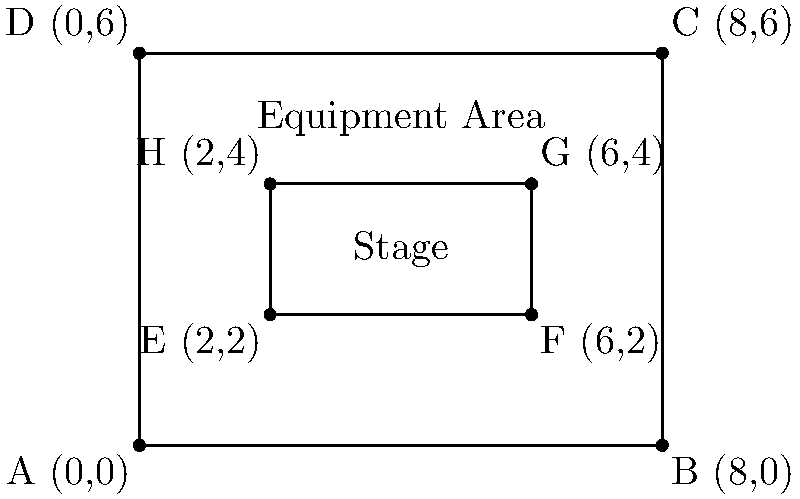As the band coach, you're planning the stage setup for the upcoming school concert. The rectangular stage has coordinates A(0,0), B(8,0), C(8,6), and D(0,6), representing its corners in yards. The sound equipment area is represented by the inner rectangle with coordinates E(2,2), F(6,2), G(6,4), and H(2,4). Calculate the area of the stage that will be available for the band members to perform, excluding the equipment area. To find the available area for the band, we need to:

1. Calculate the total area of the stage:
   $A_{stage} = length \times width = 8 \times 6 = 48$ square yards

2. Calculate the area of the equipment section:
   $A_{equipment} = length \times width = 4 \times 2 = 8$ square yards

3. Subtract the equipment area from the total stage area:
   $A_{available} = A_{stage} - A_{equipment} = 48 - 8 = 40$ square yards

Therefore, the area available for the band members to perform is 40 square yards.
Answer: 40 square yards 